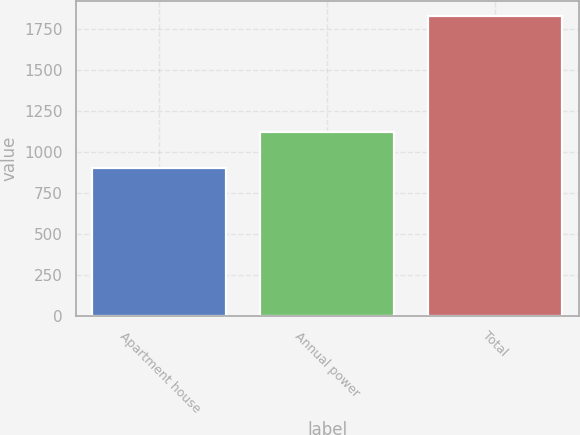Convert chart. <chart><loc_0><loc_0><loc_500><loc_500><bar_chart><fcel>Apartment house<fcel>Annual power<fcel>Total<nl><fcel>905<fcel>1119<fcel>1828<nl></chart> 